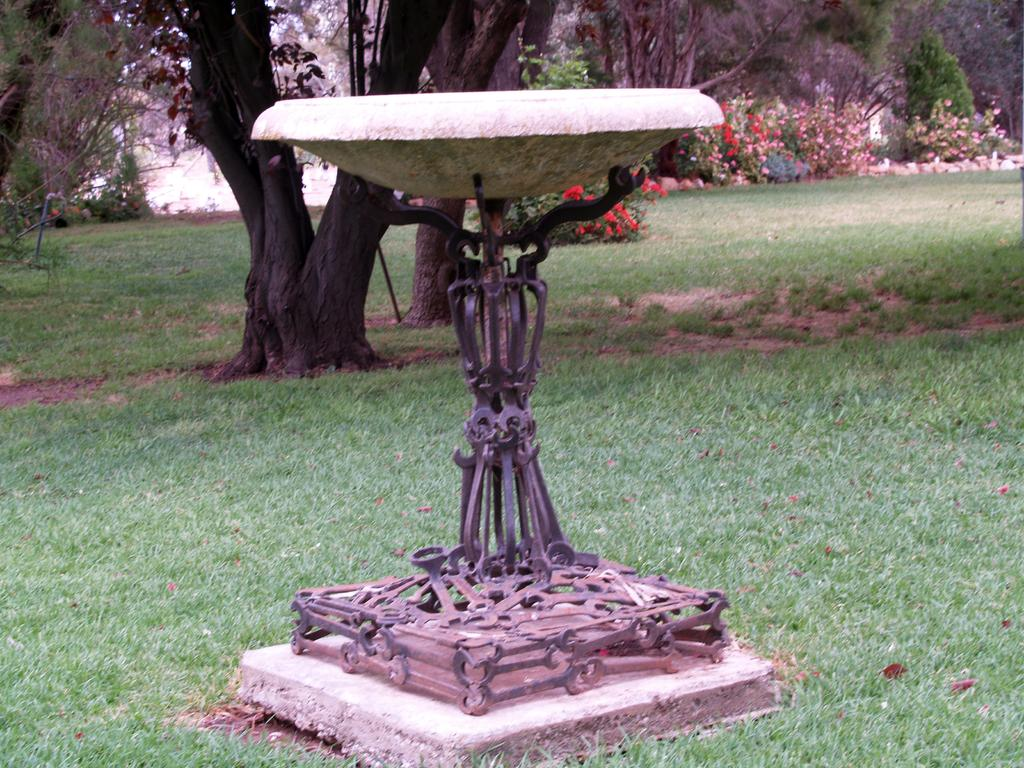What is the main feature in the image? There is a fountain in the image. Where is the fountain located? The fountain is placed on the ground. What type of vegetation is present on the ground? There is grass on the ground. What can be seen in the background of the image? There are trees and plants in the background of the image. Are there any flowers visible in the image? Yes, there are flowers associated with the plants in the background. Reasoning: Let' Let's think step by step in order to produce the conversation. We start by identifying the main subject of the image, which is the fountain. Then, we describe its location and the surrounding environment, including the grass on the ground and the trees and plants in the background. Finally, we mention the presence of flowers associated with the plants in the background. Each question is designed to elicit a specific detail about the image that is known from the provided facts. Absurd Question/Answer: What type of paint is used to color the harbor in the image? There is no harbor present in the image; it features a fountain, grass, trees, plants, and flowers. 